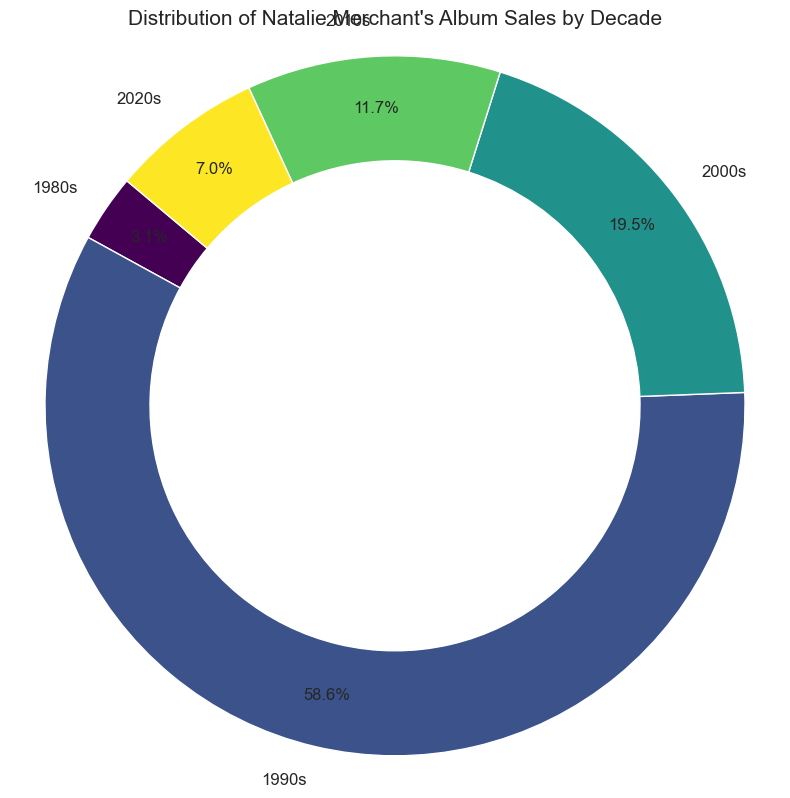Which decade had the highest album sales? By looking at the figure, we can identify the decade with the largest slice of the ring chart and the highest percentage label. The 1990s have the largest slice with 68.2% of the total album sales.
Answer: 1990s What is the sum of album sales in the 1980s and 2020s? To find the sum, we add the sales from the 1980s and 2020s: 400,000 (1980s) + 900,000 (2020s) = 1,300,000.
Answer: 1,300,000 Which decade's album sales are closest to 1,500,000? By examining the chart, the sales for the 2010s are labeled as 1,500,000, which matches the given value precisely.
Answer: 2010s How do the album sales in the 2000s compare to those in the 1980s? By visually inspecting the figure, the 2000s' slice is much larger than the 1980s', representing a significant difference. The 2000s sales are 2,500,000, while the 1980s sales are 400,000. Therefore, the 2000s had higher sales.
Answer: The 2000s had higher sales What is the average album sales per decade? To find the average, sum the sales from all decades and divide by the number of decades: (400,000 + 7,500,000 + 2,500,000 + 1,500,000 + 900,000) / 5 = 2,960,000.
Answer: 2,960,000 What is the difference in album sales between the 1990s and the 2010s? Subtract the album sales of the 2010s from those in the 1990s: 7,500,000 - 1,500,000 = 6,000,000.
Answer: 6,000,000 Which two decades combined account for over half of the total album sales? By analyzing the percentages on the chart, the 1990s (68.2%) alone already exceed half the total sales. However, combining the 1990s (68.2%) and another decade could help reconfirm. Adding the 2000s (22.7%) gives a total of 90.9%, which is well over half.
Answer: 1990s and 2000s 